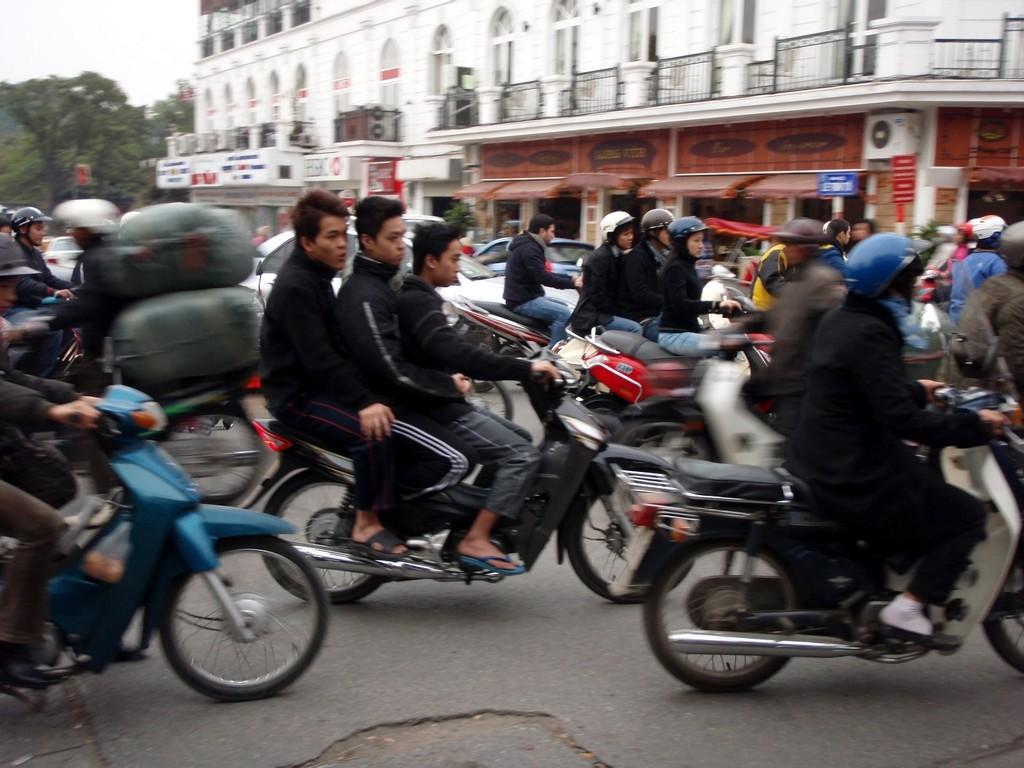In one or two sentences, can you explain what this image depicts? This is a picture taken in the outdoors. A group of people riding their bikes. Behind the people there is a building, the building in white color, trees and sky. 